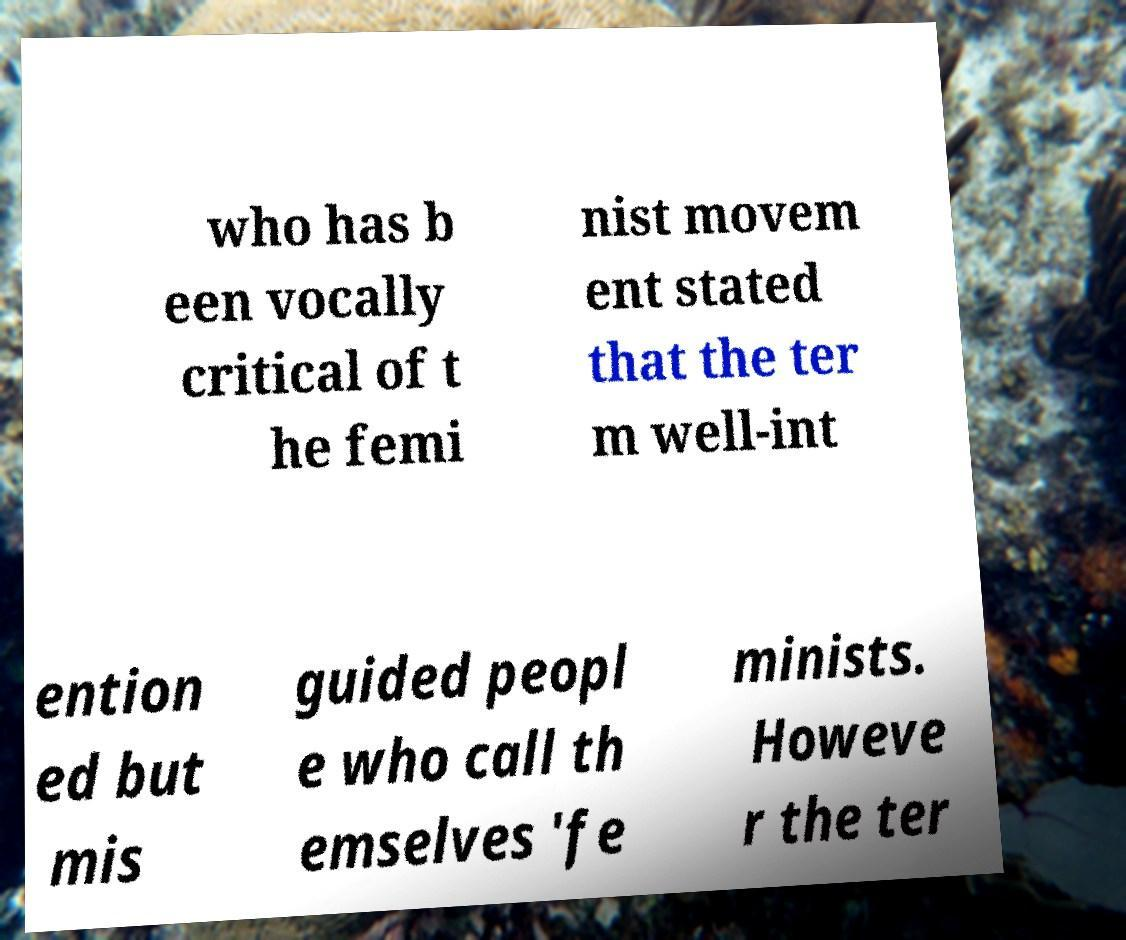What messages or text are displayed in this image? I need them in a readable, typed format. who has b een vocally critical of t he femi nist movem ent stated that the ter m well-int ention ed but mis guided peopl e who call th emselves 'fe minists. Howeve r the ter 